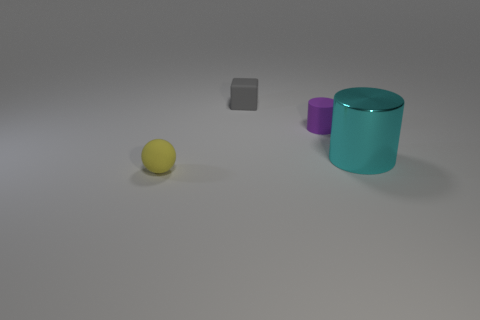Add 1 blocks. How many objects exist? 5 Add 2 tiny yellow things. How many tiny yellow things exist? 3 Subtract 0 brown cylinders. How many objects are left? 4 Subtract all green spheres. Subtract all tiny yellow matte things. How many objects are left? 3 Add 4 big cylinders. How many big cylinders are left? 5 